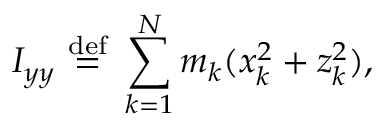Convert formula to latex. <formula><loc_0><loc_0><loc_500><loc_500>I _ { y y } \ { \stackrel { d e f } { = } } \ \sum _ { k = 1 } ^ { N } m _ { k } ( x _ { k } ^ { 2 } + z _ { k } ^ { 2 } ) , \,</formula> 